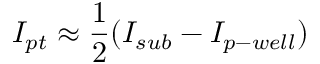Convert formula to latex. <formula><loc_0><loc_0><loc_500><loc_500>I _ { p t } \approx \frac { 1 } { 2 } ( I _ { s u b } - I _ { p - w e l l } )</formula> 